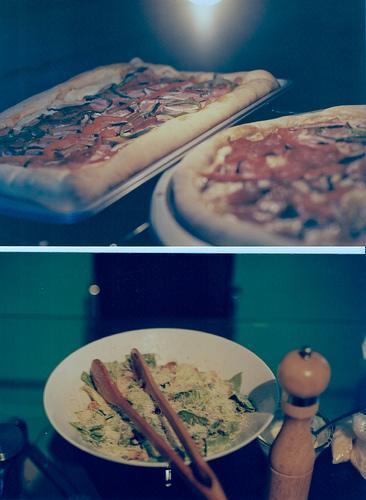How many pizzas are there?
Give a very brief answer. 2. 